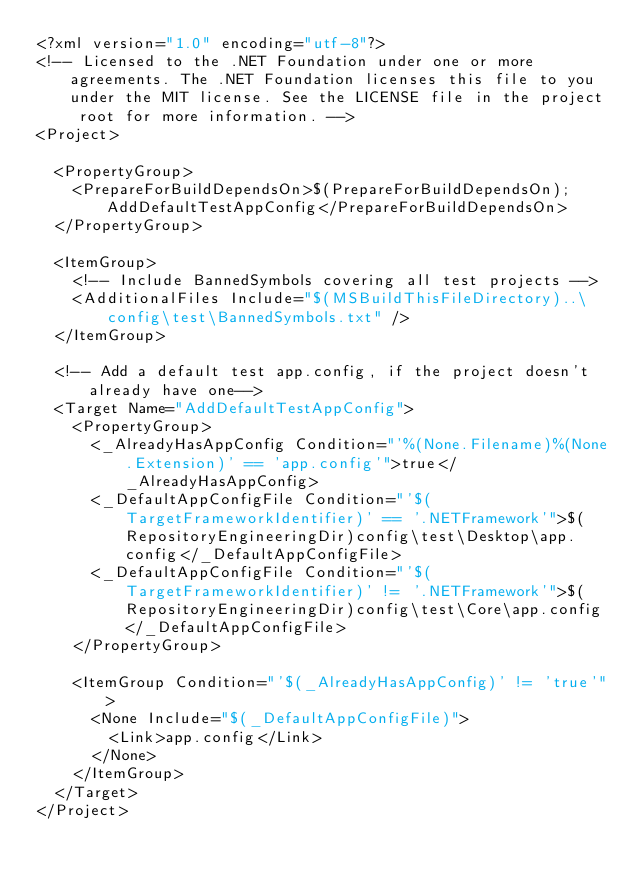Convert code to text. <code><loc_0><loc_0><loc_500><loc_500><_XML_><?xml version="1.0" encoding="utf-8"?>
<!-- Licensed to the .NET Foundation under one or more agreements. The .NET Foundation licenses this file to you under the MIT license. See the LICENSE file in the project root for more information. -->
<Project>

  <PropertyGroup>
    <PrepareForBuildDependsOn>$(PrepareForBuildDependsOn);AddDefaultTestAppConfig</PrepareForBuildDependsOn>
  </PropertyGroup>

  <ItemGroup>
    <!-- Include BannedSymbols covering all test projects -->
    <AdditionalFiles Include="$(MSBuildThisFileDirectory)..\config\test\BannedSymbols.txt" />
  </ItemGroup>

  <!-- Add a default test app.config, if the project doesn't already have one-->
  <Target Name="AddDefaultTestAppConfig">
    <PropertyGroup>
      <_AlreadyHasAppConfig Condition="'%(None.Filename)%(None.Extension)' == 'app.config'">true</_AlreadyHasAppConfig>
      <_DefaultAppConfigFile Condition="'$(TargetFrameworkIdentifier)' == '.NETFramework'">$(RepositoryEngineeringDir)config\test\Desktop\app.config</_DefaultAppConfigFile>
      <_DefaultAppConfigFile Condition="'$(TargetFrameworkIdentifier)' != '.NETFramework'">$(RepositoryEngineeringDir)config\test\Core\app.config</_DefaultAppConfigFile>
    </PropertyGroup>

    <ItemGroup Condition="'$(_AlreadyHasAppConfig)' != 'true'">
      <None Include="$(_DefaultAppConfigFile)">
        <Link>app.config</Link>
      </None>
    </ItemGroup>
  </Target>
</Project>
</code> 